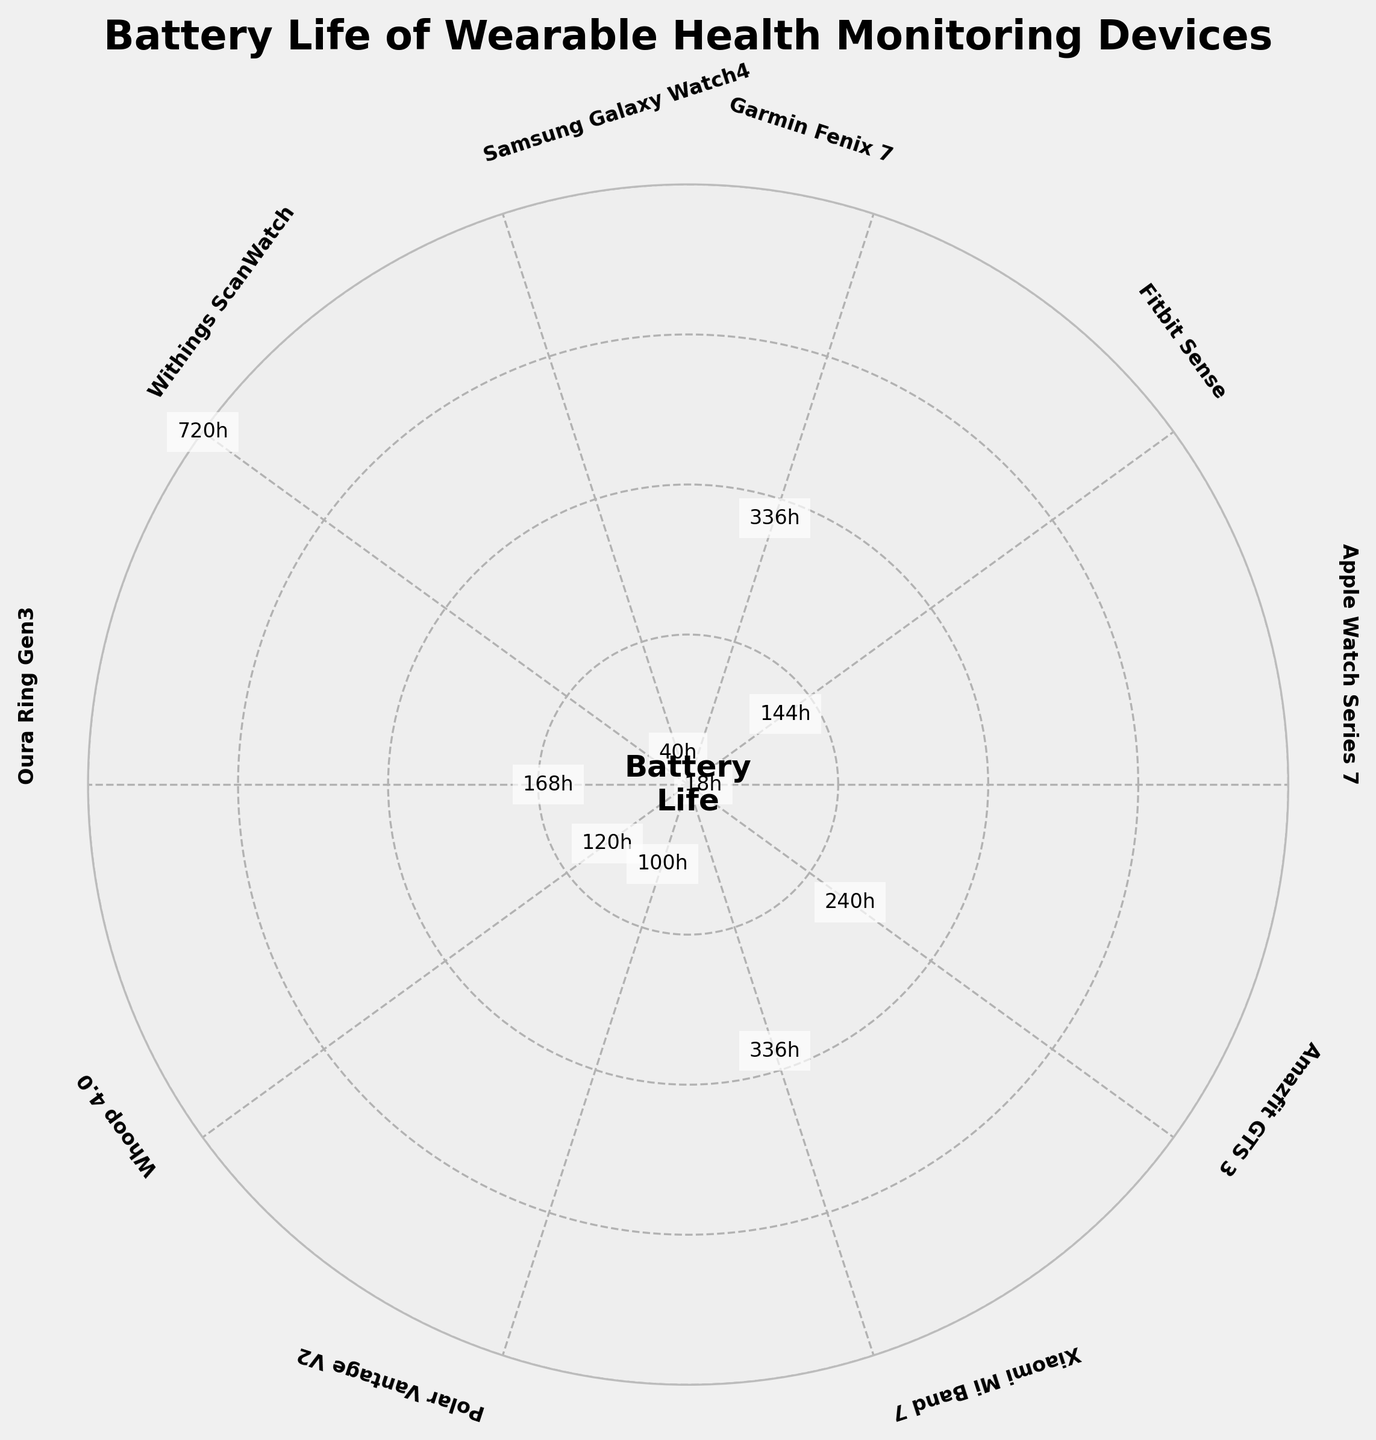what is the title of the figure? The title is displayed at the top of the figure. It reads "Battery Life of Wearable Health Monitoring Devices."
Answer: Battery Life of Wearable Health Monitoring Devices How many devices are compared in the figure? Each segment of the gauge chart represents a device. By counting the segments, we can see that there are 10 devices compared in the figure.
Answer: 10 Which device has the longest battery life? The longest battery life is indicated by the segment that extends farthest from the center of the chart. The Withings ScanWatch has the longest battery life with a value of 720 hours.
Answer: Withings ScanWatch What is the battery life of the Apple Watch Series 7? The Apple Watch Series 7 segment includes a text label showing its battery life. According to the figure, it has a battery life of 18 hours.
Answer: 18 hours How does the battery life of the Oura Ring Gen3 compare to the Whoop 4.0? By comparing the lengths of the segments for the Oura Ring Gen3 and the Whoop 4.0, we see that the Oura Ring Gen3 has a longer battery life (168 hours) than the Whoop 4.0 (120 hours).
Answer: Oura Ring Gen3 has a longer battery life What is the average battery life of all the devices? To find the average, first sum all the battery lives: 18 + 144 + 336 + 40 + 720 + 168 + 120 + 100 + 336 + 240 = 2222. Then, divide by the number of devices, which is 10. Therefore, 2222 / 10 = 222.2.
Answer: 222.2 hours How many devices have a battery life of more than 200 hours? By examining the figure, we see that there are 4 devices with battery lives exceeding 200 hours: Garmin Fenix 7 (336h), Withings ScanWatch (720h), Oura Ring Gen3 (168h), and Amazfit GTS 3 (240h).
Answer: 4 devices Which devices fall into the medium battery life category (between 100 and 300 hours)? By looking at the segments representing battery lives between 100 and 300 hours, there are Fitbit Sense (144h), Oura Ring Gen3 (168h), Whoop 4.0 (120h), Polar Vantage V2 (100h), and Amazfit GTS 3 (240h).
Answer: Fitbit Sense, Oura Ring Gen3, Whoop 4.0, Polar Vantage V2, Amazfit GTS 3 What is the total battery life for the Xiaomi Mi Band 7 and the Garmin Fenix 7 combined? The segment for Xiaomi Mi Band 7 shows a battery life of 336 hours, and Garmin Fenix 7 also shows a battery life of 336 hours. Adding them together, 336 + 336 = 672.
Answer: 672 hours What is the color scheme used in the gauge chart? The colors range from light to dark shades going from lower to higher battery life values, which is indicative of using a colormap like viridis.
Answer: light to dark shades 